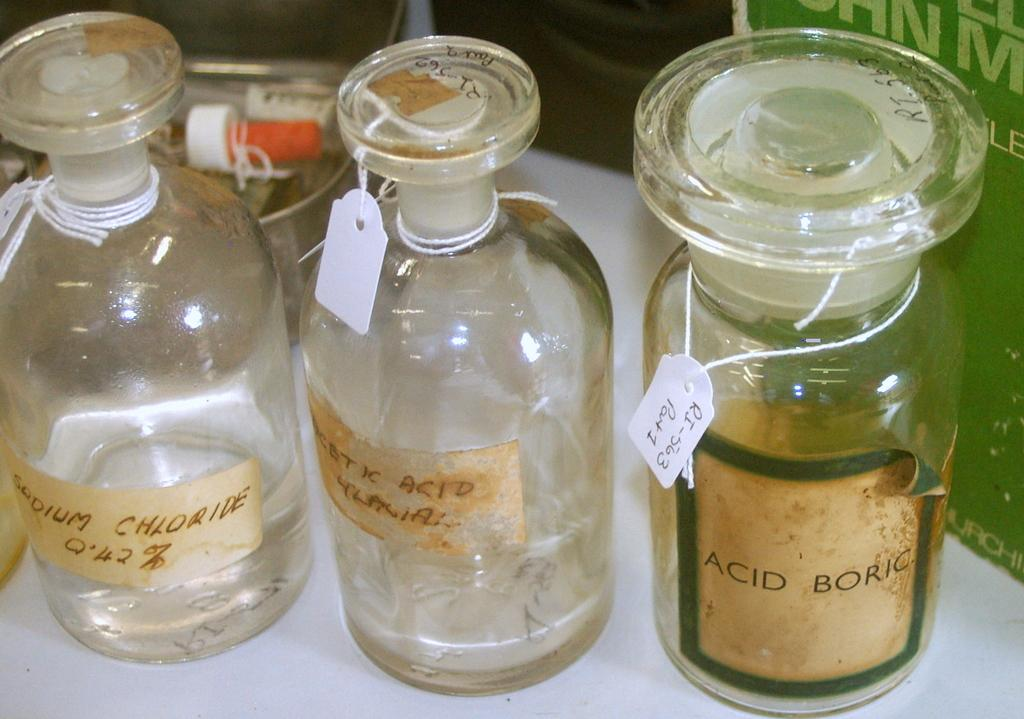<image>
Offer a succinct explanation of the picture presented. A glass jar has an acid boric label on it. 